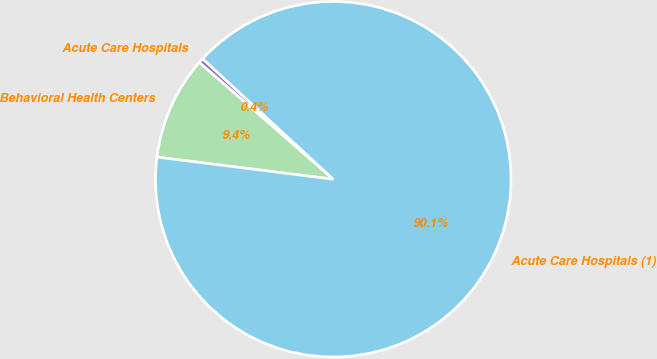<chart> <loc_0><loc_0><loc_500><loc_500><pie_chart><fcel>Acute Care Hospitals<fcel>Behavioral Health Centers<fcel>Acute Care Hospitals (1)<nl><fcel>0.45%<fcel>9.42%<fcel>90.14%<nl></chart> 